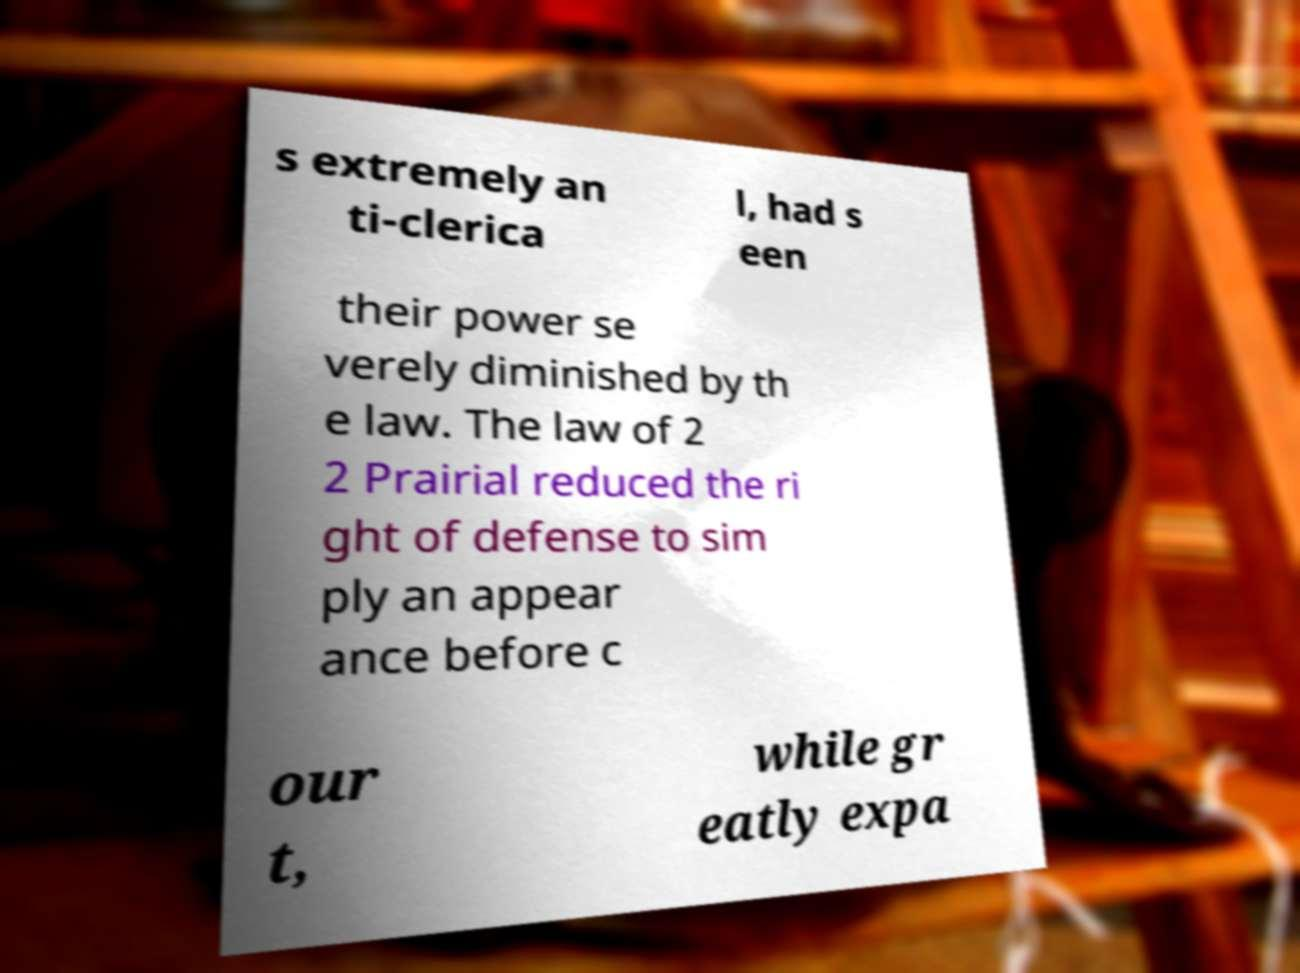For documentation purposes, I need the text within this image transcribed. Could you provide that? s extremely an ti-clerica l, had s een their power se verely diminished by th e law. The law of 2 2 Prairial reduced the ri ght of defense to sim ply an appear ance before c our t, while gr eatly expa 